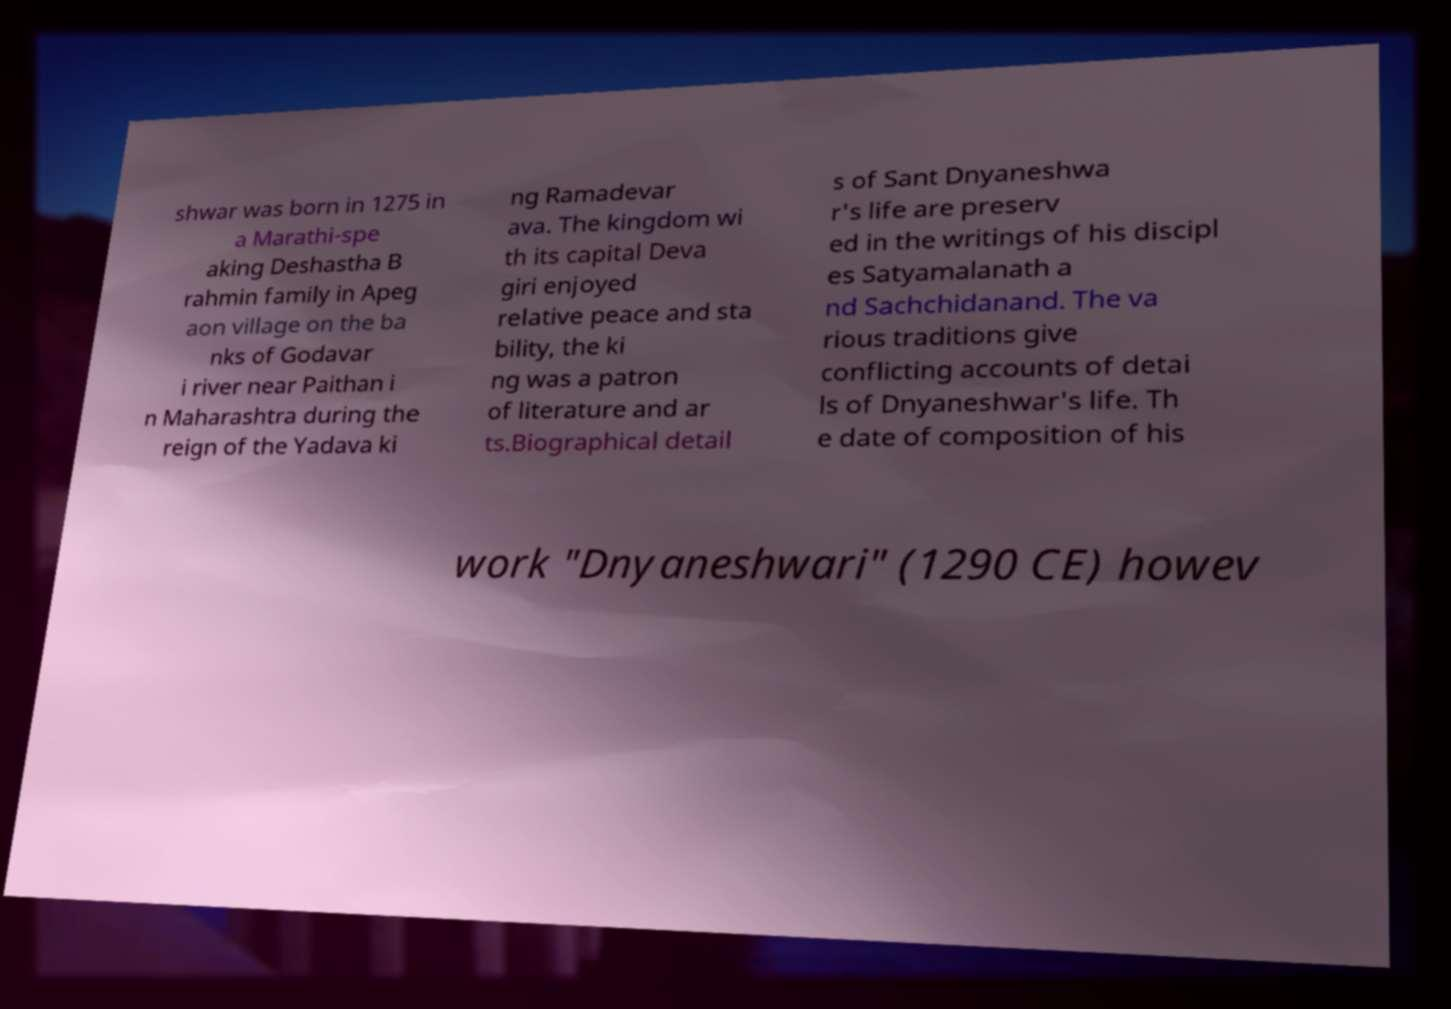Could you assist in decoding the text presented in this image and type it out clearly? shwar was born in 1275 in a Marathi-spe aking Deshastha B rahmin family in Apeg aon village on the ba nks of Godavar i river near Paithan i n Maharashtra during the reign of the Yadava ki ng Ramadevar ava. The kingdom wi th its capital Deva giri enjoyed relative peace and sta bility, the ki ng was a patron of literature and ar ts.Biographical detail s of Sant Dnyaneshwa r's life are preserv ed in the writings of his discipl es Satyamalanath a nd Sachchidanand. The va rious traditions give conflicting accounts of detai ls of Dnyaneshwar's life. Th e date of composition of his work "Dnyaneshwari" (1290 CE) howev 